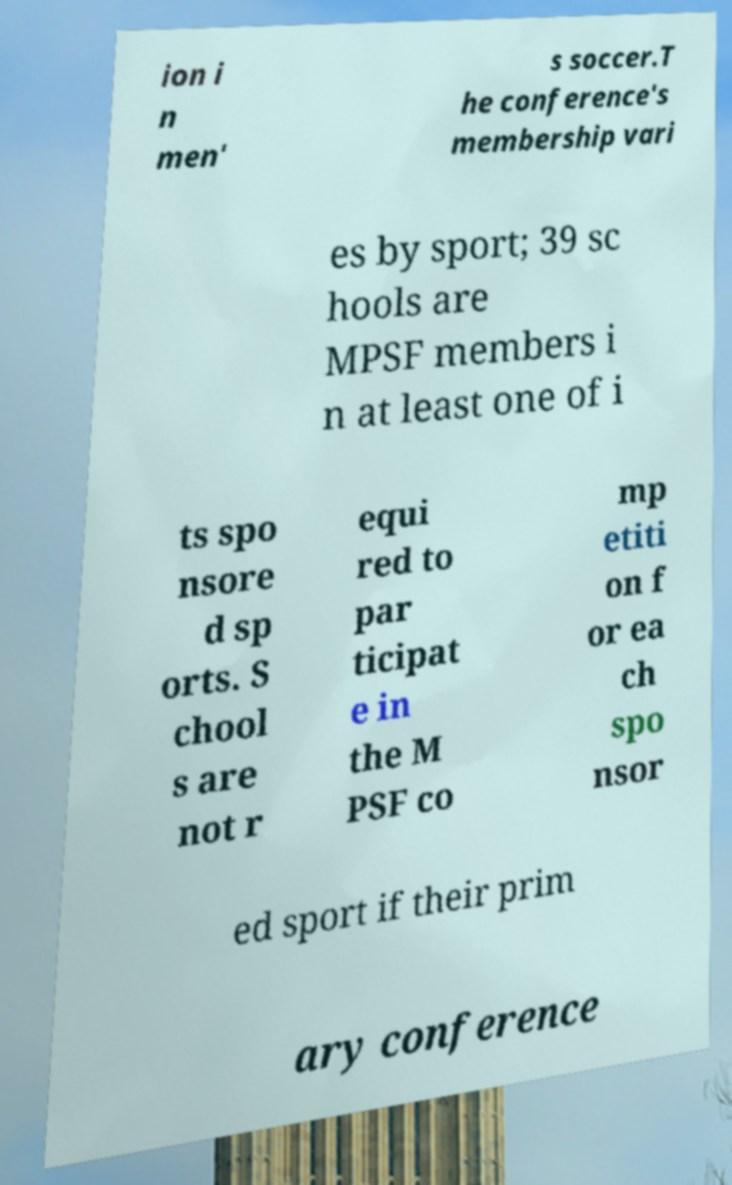I need the written content from this picture converted into text. Can you do that? ion i n men' s soccer.T he conference's membership vari es by sport; 39 sc hools are MPSF members i n at least one of i ts spo nsore d sp orts. S chool s are not r equi red to par ticipat e in the M PSF co mp etiti on f or ea ch spo nsor ed sport if their prim ary conference 